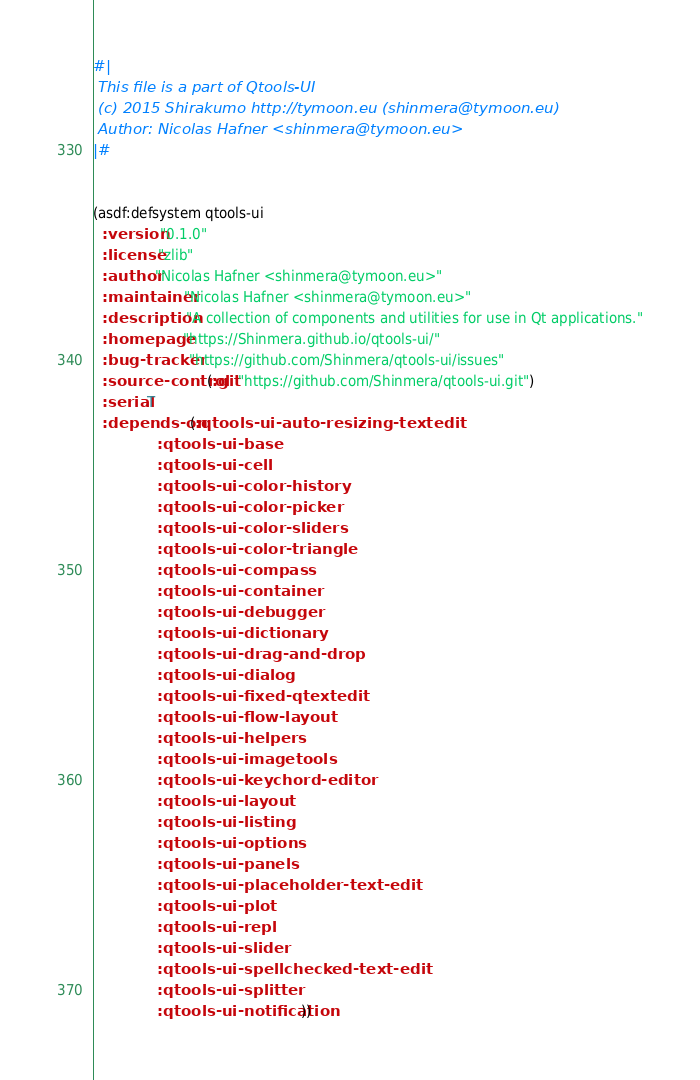Convert code to text. <code><loc_0><loc_0><loc_500><loc_500><_Lisp_>#|
 This file is a part of Qtools-UI
 (c) 2015 Shirakumo http://tymoon.eu (shinmera@tymoon.eu)
 Author: Nicolas Hafner <shinmera@tymoon.eu>
|#


(asdf:defsystem qtools-ui
  :version "0.1.0"
  :license "zlib"
  :author "Nicolas Hafner <shinmera@tymoon.eu>"
  :maintainer "Nicolas Hafner <shinmera@tymoon.eu>"
  :description "A collection of components and utilities for use in Qt applications."
  :homepage "https://Shinmera.github.io/qtools-ui/"
  :bug-tracker "https://github.com/Shinmera/qtools-ui/issues"
  :source-control (:git "https://github.com/Shinmera/qtools-ui.git")
  :serial T
  :depends-on (:qtools-ui-auto-resizing-textedit
               :qtools-ui-base
               :qtools-ui-cell
               :qtools-ui-color-history
               :qtools-ui-color-picker
               :qtools-ui-color-sliders
               :qtools-ui-color-triangle
               :qtools-ui-compass
               :qtools-ui-container
               :qtools-ui-debugger
               :qtools-ui-dictionary
               :qtools-ui-drag-and-drop
               :qtools-ui-dialog
               :qtools-ui-fixed-qtextedit
               :qtools-ui-flow-layout
               :qtools-ui-helpers
               :qtools-ui-imagetools
               :qtools-ui-keychord-editor
               :qtools-ui-layout
               :qtools-ui-listing
               :qtools-ui-options
               :qtools-ui-panels
               :qtools-ui-placeholder-text-edit
               :qtools-ui-plot
               :qtools-ui-repl
               :qtools-ui-slider
               :qtools-ui-spellchecked-text-edit
               :qtools-ui-splitter
               :qtools-ui-notification))
</code> 